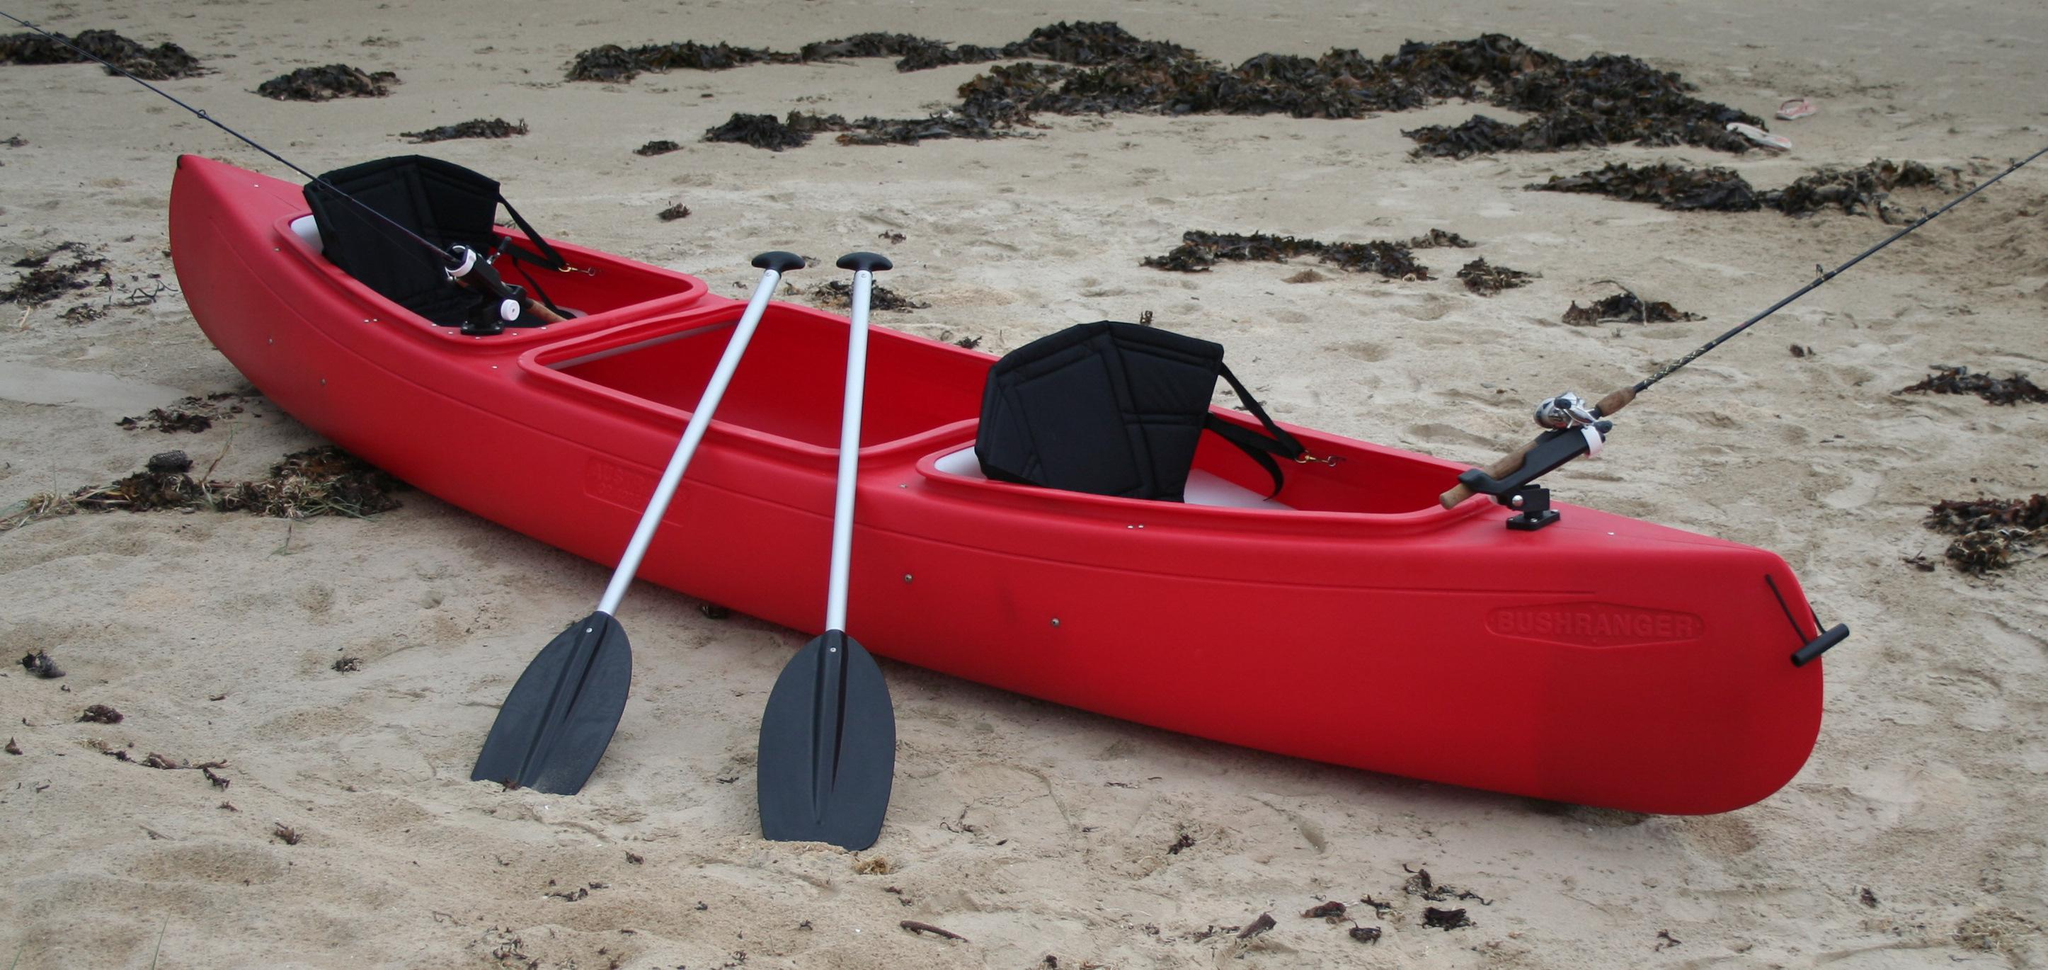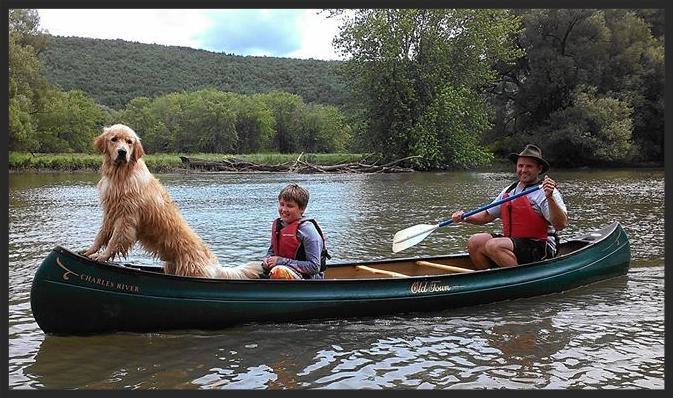The first image is the image on the left, the second image is the image on the right. Assess this claim about the two images: "There is at most 1 dog in a canoe.". Correct or not? Answer yes or no. Yes. 